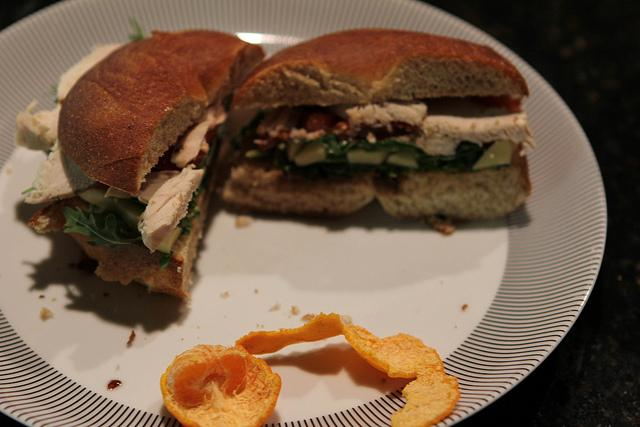Which part of this meal has a small portion?

Choices:
A) meat
B) chips
C) bread
D) veggies chips 